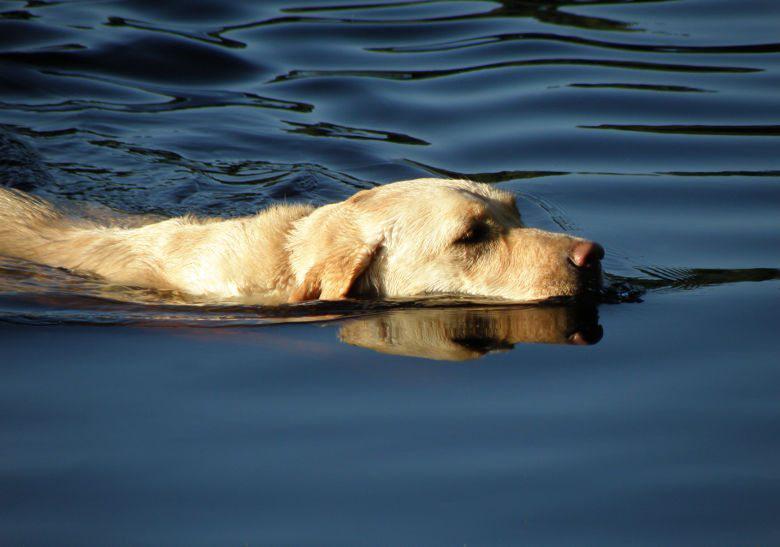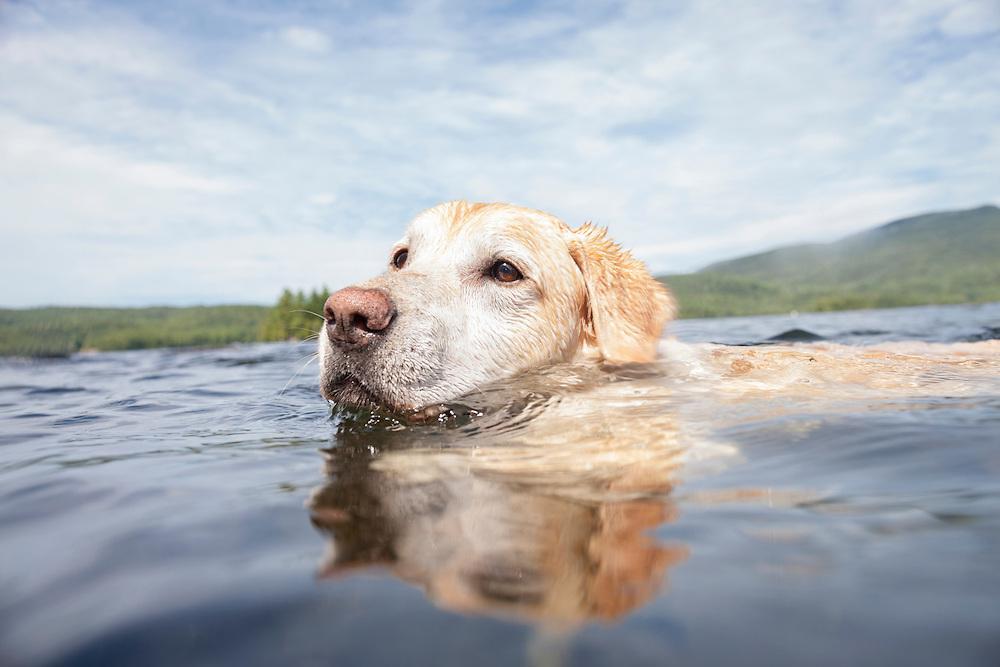The first image is the image on the left, the second image is the image on the right. Evaluate the accuracy of this statement regarding the images: "Two dogs are swimming through water up to their chin.". Is it true? Answer yes or no. Yes. 